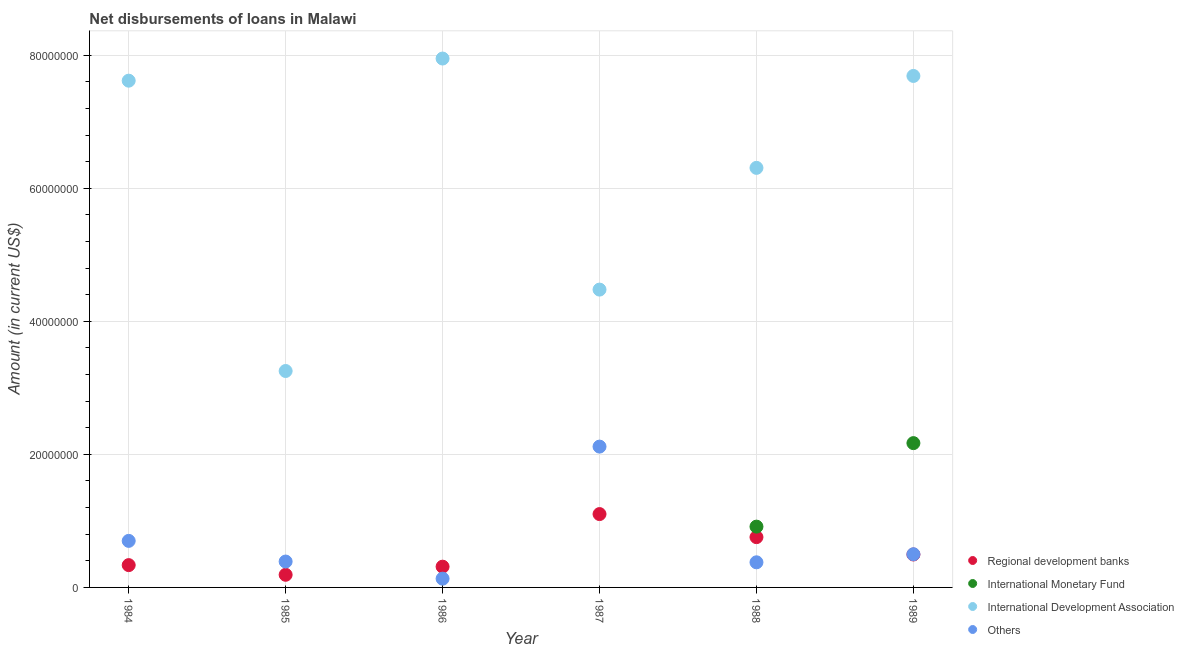Is the number of dotlines equal to the number of legend labels?
Make the answer very short. No. What is the amount of loan disimbursed by other organisations in 1988?
Ensure brevity in your answer.  3.78e+06. Across all years, what is the maximum amount of loan disimbursed by other organisations?
Provide a short and direct response. 2.12e+07. Across all years, what is the minimum amount of loan disimbursed by international development association?
Provide a short and direct response. 3.25e+07. What is the total amount of loan disimbursed by international development association in the graph?
Provide a succinct answer. 3.73e+08. What is the difference between the amount of loan disimbursed by international monetary fund in 1988 and that in 1989?
Make the answer very short. -1.26e+07. What is the difference between the amount of loan disimbursed by international development association in 1986 and the amount of loan disimbursed by international monetary fund in 1984?
Make the answer very short. 7.95e+07. What is the average amount of loan disimbursed by international monetary fund per year?
Your response must be concise. 5.14e+06. In the year 1988, what is the difference between the amount of loan disimbursed by international monetary fund and amount of loan disimbursed by regional development banks?
Offer a very short reply. 1.58e+06. In how many years, is the amount of loan disimbursed by international development association greater than 52000000 US$?
Offer a very short reply. 4. What is the ratio of the amount of loan disimbursed by international development association in 1985 to that in 1986?
Your answer should be compact. 0.41. What is the difference between the highest and the second highest amount of loan disimbursed by other organisations?
Make the answer very short. 1.42e+07. What is the difference between the highest and the lowest amount of loan disimbursed by international development association?
Keep it short and to the point. 4.70e+07. Is the sum of the amount of loan disimbursed by international development association in 1988 and 1989 greater than the maximum amount of loan disimbursed by other organisations across all years?
Your answer should be very brief. Yes. Is it the case that in every year, the sum of the amount of loan disimbursed by regional development banks and amount of loan disimbursed by international monetary fund is greater than the amount of loan disimbursed by international development association?
Ensure brevity in your answer.  No. Does the amount of loan disimbursed by other organisations monotonically increase over the years?
Offer a terse response. No. How many dotlines are there?
Offer a terse response. 4. How many years are there in the graph?
Provide a succinct answer. 6. Are the values on the major ticks of Y-axis written in scientific E-notation?
Offer a terse response. No. Does the graph contain grids?
Offer a terse response. Yes. Where does the legend appear in the graph?
Provide a short and direct response. Bottom right. How many legend labels are there?
Keep it short and to the point. 4. What is the title of the graph?
Your answer should be very brief. Net disbursements of loans in Malawi. What is the label or title of the Y-axis?
Offer a terse response. Amount (in current US$). What is the Amount (in current US$) in Regional development banks in 1984?
Offer a terse response. 3.35e+06. What is the Amount (in current US$) of International Monetary Fund in 1984?
Your response must be concise. 0. What is the Amount (in current US$) of International Development Association in 1984?
Make the answer very short. 7.62e+07. What is the Amount (in current US$) of Others in 1984?
Offer a very short reply. 7.00e+06. What is the Amount (in current US$) of Regional development banks in 1985?
Keep it short and to the point. 1.90e+06. What is the Amount (in current US$) in International Monetary Fund in 1985?
Provide a succinct answer. 0. What is the Amount (in current US$) in International Development Association in 1985?
Your answer should be very brief. 3.25e+07. What is the Amount (in current US$) of Others in 1985?
Provide a short and direct response. 3.89e+06. What is the Amount (in current US$) in Regional development banks in 1986?
Give a very brief answer. 3.12e+06. What is the Amount (in current US$) of International Monetary Fund in 1986?
Offer a terse response. 0. What is the Amount (in current US$) of International Development Association in 1986?
Provide a short and direct response. 7.95e+07. What is the Amount (in current US$) of Others in 1986?
Provide a short and direct response. 1.32e+06. What is the Amount (in current US$) of Regional development banks in 1987?
Your response must be concise. 1.10e+07. What is the Amount (in current US$) in International Monetary Fund in 1987?
Make the answer very short. 0. What is the Amount (in current US$) of International Development Association in 1987?
Provide a succinct answer. 4.48e+07. What is the Amount (in current US$) in Others in 1987?
Your answer should be very brief. 2.12e+07. What is the Amount (in current US$) in Regional development banks in 1988?
Offer a terse response. 7.56e+06. What is the Amount (in current US$) in International Monetary Fund in 1988?
Ensure brevity in your answer.  9.14e+06. What is the Amount (in current US$) in International Development Association in 1988?
Ensure brevity in your answer.  6.31e+07. What is the Amount (in current US$) in Others in 1988?
Offer a terse response. 3.78e+06. What is the Amount (in current US$) of Regional development banks in 1989?
Provide a short and direct response. 4.95e+06. What is the Amount (in current US$) of International Monetary Fund in 1989?
Make the answer very short. 2.17e+07. What is the Amount (in current US$) of International Development Association in 1989?
Give a very brief answer. 7.69e+07. What is the Amount (in current US$) of Others in 1989?
Keep it short and to the point. 4.99e+06. Across all years, what is the maximum Amount (in current US$) in Regional development banks?
Your answer should be very brief. 1.10e+07. Across all years, what is the maximum Amount (in current US$) of International Monetary Fund?
Make the answer very short. 2.17e+07. Across all years, what is the maximum Amount (in current US$) of International Development Association?
Make the answer very short. 7.95e+07. Across all years, what is the maximum Amount (in current US$) of Others?
Your answer should be very brief. 2.12e+07. Across all years, what is the minimum Amount (in current US$) in Regional development banks?
Offer a very short reply. 1.90e+06. Across all years, what is the minimum Amount (in current US$) in International Monetary Fund?
Offer a very short reply. 0. Across all years, what is the minimum Amount (in current US$) in International Development Association?
Give a very brief answer. 3.25e+07. Across all years, what is the minimum Amount (in current US$) of Others?
Give a very brief answer. 1.32e+06. What is the total Amount (in current US$) in Regional development banks in the graph?
Ensure brevity in your answer.  3.19e+07. What is the total Amount (in current US$) in International Monetary Fund in the graph?
Provide a short and direct response. 3.08e+07. What is the total Amount (in current US$) in International Development Association in the graph?
Keep it short and to the point. 3.73e+08. What is the total Amount (in current US$) in Others in the graph?
Provide a short and direct response. 4.21e+07. What is the difference between the Amount (in current US$) in Regional development banks in 1984 and that in 1985?
Give a very brief answer. 1.45e+06. What is the difference between the Amount (in current US$) in International Development Association in 1984 and that in 1985?
Offer a very short reply. 4.36e+07. What is the difference between the Amount (in current US$) of Others in 1984 and that in 1985?
Give a very brief answer. 3.11e+06. What is the difference between the Amount (in current US$) in Regional development banks in 1984 and that in 1986?
Offer a terse response. 2.34e+05. What is the difference between the Amount (in current US$) in International Development Association in 1984 and that in 1986?
Provide a succinct answer. -3.33e+06. What is the difference between the Amount (in current US$) of Others in 1984 and that in 1986?
Provide a succinct answer. 5.68e+06. What is the difference between the Amount (in current US$) in Regional development banks in 1984 and that in 1987?
Provide a short and direct response. -7.67e+06. What is the difference between the Amount (in current US$) in International Development Association in 1984 and that in 1987?
Give a very brief answer. 3.14e+07. What is the difference between the Amount (in current US$) in Others in 1984 and that in 1987?
Offer a very short reply. -1.42e+07. What is the difference between the Amount (in current US$) in Regional development banks in 1984 and that in 1988?
Ensure brevity in your answer.  -4.21e+06. What is the difference between the Amount (in current US$) in International Development Association in 1984 and that in 1988?
Make the answer very short. 1.31e+07. What is the difference between the Amount (in current US$) of Others in 1984 and that in 1988?
Keep it short and to the point. 3.22e+06. What is the difference between the Amount (in current US$) of Regional development banks in 1984 and that in 1989?
Your answer should be very brief. -1.60e+06. What is the difference between the Amount (in current US$) in International Development Association in 1984 and that in 1989?
Your answer should be very brief. -7.12e+05. What is the difference between the Amount (in current US$) of Others in 1984 and that in 1989?
Ensure brevity in your answer.  2.01e+06. What is the difference between the Amount (in current US$) of Regional development banks in 1985 and that in 1986?
Your response must be concise. -1.22e+06. What is the difference between the Amount (in current US$) of International Development Association in 1985 and that in 1986?
Your answer should be very brief. -4.70e+07. What is the difference between the Amount (in current US$) of Others in 1985 and that in 1986?
Keep it short and to the point. 2.58e+06. What is the difference between the Amount (in current US$) in Regional development banks in 1985 and that in 1987?
Your answer should be very brief. -9.13e+06. What is the difference between the Amount (in current US$) in International Development Association in 1985 and that in 1987?
Your response must be concise. -1.22e+07. What is the difference between the Amount (in current US$) in Others in 1985 and that in 1987?
Your answer should be very brief. -1.73e+07. What is the difference between the Amount (in current US$) in Regional development banks in 1985 and that in 1988?
Make the answer very short. -5.66e+06. What is the difference between the Amount (in current US$) of International Development Association in 1985 and that in 1988?
Your response must be concise. -3.05e+07. What is the difference between the Amount (in current US$) of Others in 1985 and that in 1988?
Give a very brief answer. 1.15e+05. What is the difference between the Amount (in current US$) of Regional development banks in 1985 and that in 1989?
Your response must be concise. -3.05e+06. What is the difference between the Amount (in current US$) of International Development Association in 1985 and that in 1989?
Keep it short and to the point. -4.44e+07. What is the difference between the Amount (in current US$) of Others in 1985 and that in 1989?
Keep it short and to the point. -1.10e+06. What is the difference between the Amount (in current US$) in Regional development banks in 1986 and that in 1987?
Keep it short and to the point. -7.91e+06. What is the difference between the Amount (in current US$) of International Development Association in 1986 and that in 1987?
Offer a very short reply. 3.47e+07. What is the difference between the Amount (in current US$) of Others in 1986 and that in 1987?
Offer a terse response. -1.99e+07. What is the difference between the Amount (in current US$) in Regional development banks in 1986 and that in 1988?
Offer a terse response. -4.44e+06. What is the difference between the Amount (in current US$) of International Development Association in 1986 and that in 1988?
Ensure brevity in your answer.  1.64e+07. What is the difference between the Amount (in current US$) in Others in 1986 and that in 1988?
Offer a very short reply. -2.46e+06. What is the difference between the Amount (in current US$) of Regional development banks in 1986 and that in 1989?
Provide a succinct answer. -1.83e+06. What is the difference between the Amount (in current US$) of International Development Association in 1986 and that in 1989?
Ensure brevity in your answer.  2.62e+06. What is the difference between the Amount (in current US$) in Others in 1986 and that in 1989?
Make the answer very short. -3.67e+06. What is the difference between the Amount (in current US$) in Regional development banks in 1987 and that in 1988?
Your answer should be compact. 3.47e+06. What is the difference between the Amount (in current US$) of International Development Association in 1987 and that in 1988?
Offer a very short reply. -1.83e+07. What is the difference between the Amount (in current US$) in Others in 1987 and that in 1988?
Ensure brevity in your answer.  1.74e+07. What is the difference between the Amount (in current US$) in Regional development banks in 1987 and that in 1989?
Offer a terse response. 6.08e+06. What is the difference between the Amount (in current US$) of International Development Association in 1987 and that in 1989?
Keep it short and to the point. -3.21e+07. What is the difference between the Amount (in current US$) in Others in 1987 and that in 1989?
Give a very brief answer. 1.62e+07. What is the difference between the Amount (in current US$) of Regional development banks in 1988 and that in 1989?
Offer a very short reply. 2.61e+06. What is the difference between the Amount (in current US$) of International Monetary Fund in 1988 and that in 1989?
Keep it short and to the point. -1.26e+07. What is the difference between the Amount (in current US$) of International Development Association in 1988 and that in 1989?
Offer a terse response. -1.38e+07. What is the difference between the Amount (in current US$) of Others in 1988 and that in 1989?
Provide a short and direct response. -1.21e+06. What is the difference between the Amount (in current US$) of Regional development banks in 1984 and the Amount (in current US$) of International Development Association in 1985?
Give a very brief answer. -2.92e+07. What is the difference between the Amount (in current US$) of Regional development banks in 1984 and the Amount (in current US$) of Others in 1985?
Ensure brevity in your answer.  -5.38e+05. What is the difference between the Amount (in current US$) of International Development Association in 1984 and the Amount (in current US$) of Others in 1985?
Make the answer very short. 7.23e+07. What is the difference between the Amount (in current US$) of Regional development banks in 1984 and the Amount (in current US$) of International Development Association in 1986?
Your response must be concise. -7.62e+07. What is the difference between the Amount (in current US$) of Regional development banks in 1984 and the Amount (in current US$) of Others in 1986?
Your answer should be compact. 2.04e+06. What is the difference between the Amount (in current US$) in International Development Association in 1984 and the Amount (in current US$) in Others in 1986?
Keep it short and to the point. 7.49e+07. What is the difference between the Amount (in current US$) of Regional development banks in 1984 and the Amount (in current US$) of International Development Association in 1987?
Your answer should be very brief. -4.14e+07. What is the difference between the Amount (in current US$) in Regional development banks in 1984 and the Amount (in current US$) in Others in 1987?
Keep it short and to the point. -1.78e+07. What is the difference between the Amount (in current US$) in International Development Association in 1984 and the Amount (in current US$) in Others in 1987?
Offer a terse response. 5.50e+07. What is the difference between the Amount (in current US$) in Regional development banks in 1984 and the Amount (in current US$) in International Monetary Fund in 1988?
Your response must be concise. -5.78e+06. What is the difference between the Amount (in current US$) of Regional development banks in 1984 and the Amount (in current US$) of International Development Association in 1988?
Offer a terse response. -5.97e+07. What is the difference between the Amount (in current US$) in Regional development banks in 1984 and the Amount (in current US$) in Others in 1988?
Your answer should be very brief. -4.23e+05. What is the difference between the Amount (in current US$) of International Development Association in 1984 and the Amount (in current US$) of Others in 1988?
Provide a short and direct response. 7.24e+07. What is the difference between the Amount (in current US$) of Regional development banks in 1984 and the Amount (in current US$) of International Monetary Fund in 1989?
Provide a succinct answer. -1.83e+07. What is the difference between the Amount (in current US$) of Regional development banks in 1984 and the Amount (in current US$) of International Development Association in 1989?
Keep it short and to the point. -7.35e+07. What is the difference between the Amount (in current US$) in Regional development banks in 1984 and the Amount (in current US$) in Others in 1989?
Your response must be concise. -1.64e+06. What is the difference between the Amount (in current US$) of International Development Association in 1984 and the Amount (in current US$) of Others in 1989?
Your answer should be very brief. 7.12e+07. What is the difference between the Amount (in current US$) in Regional development banks in 1985 and the Amount (in current US$) in International Development Association in 1986?
Make the answer very short. -7.76e+07. What is the difference between the Amount (in current US$) in Regional development banks in 1985 and the Amount (in current US$) in Others in 1986?
Your answer should be very brief. 5.84e+05. What is the difference between the Amount (in current US$) of International Development Association in 1985 and the Amount (in current US$) of Others in 1986?
Ensure brevity in your answer.  3.12e+07. What is the difference between the Amount (in current US$) of Regional development banks in 1985 and the Amount (in current US$) of International Development Association in 1987?
Offer a very short reply. -4.29e+07. What is the difference between the Amount (in current US$) of Regional development banks in 1985 and the Amount (in current US$) of Others in 1987?
Provide a succinct answer. -1.93e+07. What is the difference between the Amount (in current US$) of International Development Association in 1985 and the Amount (in current US$) of Others in 1987?
Your response must be concise. 1.14e+07. What is the difference between the Amount (in current US$) in Regional development banks in 1985 and the Amount (in current US$) in International Monetary Fund in 1988?
Give a very brief answer. -7.24e+06. What is the difference between the Amount (in current US$) in Regional development banks in 1985 and the Amount (in current US$) in International Development Association in 1988?
Keep it short and to the point. -6.12e+07. What is the difference between the Amount (in current US$) in Regional development banks in 1985 and the Amount (in current US$) in Others in 1988?
Give a very brief answer. -1.88e+06. What is the difference between the Amount (in current US$) in International Development Association in 1985 and the Amount (in current US$) in Others in 1988?
Offer a very short reply. 2.88e+07. What is the difference between the Amount (in current US$) in Regional development banks in 1985 and the Amount (in current US$) in International Monetary Fund in 1989?
Your answer should be compact. -1.98e+07. What is the difference between the Amount (in current US$) in Regional development banks in 1985 and the Amount (in current US$) in International Development Association in 1989?
Ensure brevity in your answer.  -7.50e+07. What is the difference between the Amount (in current US$) in Regional development banks in 1985 and the Amount (in current US$) in Others in 1989?
Keep it short and to the point. -3.09e+06. What is the difference between the Amount (in current US$) of International Development Association in 1985 and the Amount (in current US$) of Others in 1989?
Your answer should be compact. 2.75e+07. What is the difference between the Amount (in current US$) in Regional development banks in 1986 and the Amount (in current US$) in International Development Association in 1987?
Offer a terse response. -4.17e+07. What is the difference between the Amount (in current US$) in Regional development banks in 1986 and the Amount (in current US$) in Others in 1987?
Your response must be concise. -1.80e+07. What is the difference between the Amount (in current US$) in International Development Association in 1986 and the Amount (in current US$) in Others in 1987?
Ensure brevity in your answer.  5.83e+07. What is the difference between the Amount (in current US$) in Regional development banks in 1986 and the Amount (in current US$) in International Monetary Fund in 1988?
Make the answer very short. -6.02e+06. What is the difference between the Amount (in current US$) of Regional development banks in 1986 and the Amount (in current US$) of International Development Association in 1988?
Make the answer very short. -6.00e+07. What is the difference between the Amount (in current US$) in Regional development banks in 1986 and the Amount (in current US$) in Others in 1988?
Ensure brevity in your answer.  -6.57e+05. What is the difference between the Amount (in current US$) in International Development Association in 1986 and the Amount (in current US$) in Others in 1988?
Offer a terse response. 7.57e+07. What is the difference between the Amount (in current US$) in Regional development banks in 1986 and the Amount (in current US$) in International Monetary Fund in 1989?
Give a very brief answer. -1.86e+07. What is the difference between the Amount (in current US$) in Regional development banks in 1986 and the Amount (in current US$) in International Development Association in 1989?
Provide a succinct answer. -7.38e+07. What is the difference between the Amount (in current US$) in Regional development banks in 1986 and the Amount (in current US$) in Others in 1989?
Your response must be concise. -1.87e+06. What is the difference between the Amount (in current US$) in International Development Association in 1986 and the Amount (in current US$) in Others in 1989?
Ensure brevity in your answer.  7.45e+07. What is the difference between the Amount (in current US$) in Regional development banks in 1987 and the Amount (in current US$) in International Monetary Fund in 1988?
Offer a terse response. 1.89e+06. What is the difference between the Amount (in current US$) of Regional development banks in 1987 and the Amount (in current US$) of International Development Association in 1988?
Your answer should be very brief. -5.20e+07. What is the difference between the Amount (in current US$) of Regional development banks in 1987 and the Amount (in current US$) of Others in 1988?
Keep it short and to the point. 7.25e+06. What is the difference between the Amount (in current US$) in International Development Association in 1987 and the Amount (in current US$) in Others in 1988?
Your answer should be very brief. 4.10e+07. What is the difference between the Amount (in current US$) of Regional development banks in 1987 and the Amount (in current US$) of International Monetary Fund in 1989?
Keep it short and to the point. -1.07e+07. What is the difference between the Amount (in current US$) in Regional development banks in 1987 and the Amount (in current US$) in International Development Association in 1989?
Make the answer very short. -6.59e+07. What is the difference between the Amount (in current US$) of Regional development banks in 1987 and the Amount (in current US$) of Others in 1989?
Keep it short and to the point. 6.04e+06. What is the difference between the Amount (in current US$) in International Development Association in 1987 and the Amount (in current US$) in Others in 1989?
Offer a very short reply. 3.98e+07. What is the difference between the Amount (in current US$) in Regional development banks in 1988 and the Amount (in current US$) in International Monetary Fund in 1989?
Provide a succinct answer. -1.41e+07. What is the difference between the Amount (in current US$) in Regional development banks in 1988 and the Amount (in current US$) in International Development Association in 1989?
Your response must be concise. -6.93e+07. What is the difference between the Amount (in current US$) of Regional development banks in 1988 and the Amount (in current US$) of Others in 1989?
Give a very brief answer. 2.57e+06. What is the difference between the Amount (in current US$) in International Monetary Fund in 1988 and the Amount (in current US$) in International Development Association in 1989?
Ensure brevity in your answer.  -6.78e+07. What is the difference between the Amount (in current US$) of International Monetary Fund in 1988 and the Amount (in current US$) of Others in 1989?
Provide a short and direct response. 4.15e+06. What is the difference between the Amount (in current US$) of International Development Association in 1988 and the Amount (in current US$) of Others in 1989?
Ensure brevity in your answer.  5.81e+07. What is the average Amount (in current US$) in Regional development banks per year?
Offer a terse response. 5.32e+06. What is the average Amount (in current US$) in International Monetary Fund per year?
Make the answer very short. 5.14e+06. What is the average Amount (in current US$) of International Development Association per year?
Make the answer very short. 6.22e+07. What is the average Amount (in current US$) in Others per year?
Offer a very short reply. 7.02e+06. In the year 1984, what is the difference between the Amount (in current US$) of Regional development banks and Amount (in current US$) of International Development Association?
Your answer should be very brief. -7.28e+07. In the year 1984, what is the difference between the Amount (in current US$) in Regional development banks and Amount (in current US$) in Others?
Make the answer very short. -3.64e+06. In the year 1984, what is the difference between the Amount (in current US$) of International Development Association and Amount (in current US$) of Others?
Provide a short and direct response. 6.92e+07. In the year 1985, what is the difference between the Amount (in current US$) of Regional development banks and Amount (in current US$) of International Development Association?
Offer a very short reply. -3.06e+07. In the year 1985, what is the difference between the Amount (in current US$) in Regional development banks and Amount (in current US$) in Others?
Keep it short and to the point. -1.99e+06. In the year 1985, what is the difference between the Amount (in current US$) in International Development Association and Amount (in current US$) in Others?
Ensure brevity in your answer.  2.86e+07. In the year 1986, what is the difference between the Amount (in current US$) in Regional development banks and Amount (in current US$) in International Development Association?
Provide a succinct answer. -7.64e+07. In the year 1986, what is the difference between the Amount (in current US$) in Regional development banks and Amount (in current US$) in Others?
Keep it short and to the point. 1.80e+06. In the year 1986, what is the difference between the Amount (in current US$) in International Development Association and Amount (in current US$) in Others?
Your answer should be compact. 7.82e+07. In the year 1987, what is the difference between the Amount (in current US$) in Regional development banks and Amount (in current US$) in International Development Association?
Give a very brief answer. -3.37e+07. In the year 1987, what is the difference between the Amount (in current US$) in Regional development banks and Amount (in current US$) in Others?
Provide a succinct answer. -1.01e+07. In the year 1987, what is the difference between the Amount (in current US$) in International Development Association and Amount (in current US$) in Others?
Provide a short and direct response. 2.36e+07. In the year 1988, what is the difference between the Amount (in current US$) of Regional development banks and Amount (in current US$) of International Monetary Fund?
Provide a succinct answer. -1.58e+06. In the year 1988, what is the difference between the Amount (in current US$) in Regional development banks and Amount (in current US$) in International Development Association?
Give a very brief answer. -5.55e+07. In the year 1988, what is the difference between the Amount (in current US$) in Regional development banks and Amount (in current US$) in Others?
Your response must be concise. 3.78e+06. In the year 1988, what is the difference between the Amount (in current US$) in International Monetary Fund and Amount (in current US$) in International Development Association?
Offer a very short reply. -5.39e+07. In the year 1988, what is the difference between the Amount (in current US$) of International Monetary Fund and Amount (in current US$) of Others?
Provide a succinct answer. 5.36e+06. In the year 1988, what is the difference between the Amount (in current US$) of International Development Association and Amount (in current US$) of Others?
Provide a short and direct response. 5.93e+07. In the year 1989, what is the difference between the Amount (in current US$) of Regional development banks and Amount (in current US$) of International Monetary Fund?
Your answer should be very brief. -1.67e+07. In the year 1989, what is the difference between the Amount (in current US$) in Regional development banks and Amount (in current US$) in International Development Association?
Make the answer very short. -7.19e+07. In the year 1989, what is the difference between the Amount (in current US$) of Regional development banks and Amount (in current US$) of Others?
Make the answer very short. -4.00e+04. In the year 1989, what is the difference between the Amount (in current US$) in International Monetary Fund and Amount (in current US$) in International Development Association?
Make the answer very short. -5.52e+07. In the year 1989, what is the difference between the Amount (in current US$) of International Monetary Fund and Amount (in current US$) of Others?
Keep it short and to the point. 1.67e+07. In the year 1989, what is the difference between the Amount (in current US$) in International Development Association and Amount (in current US$) in Others?
Your response must be concise. 7.19e+07. What is the ratio of the Amount (in current US$) of Regional development banks in 1984 to that in 1985?
Make the answer very short. 1.77. What is the ratio of the Amount (in current US$) in International Development Association in 1984 to that in 1985?
Offer a terse response. 2.34. What is the ratio of the Amount (in current US$) in Others in 1984 to that in 1985?
Provide a succinct answer. 1.8. What is the ratio of the Amount (in current US$) of Regional development banks in 1984 to that in 1986?
Offer a terse response. 1.07. What is the ratio of the Amount (in current US$) of International Development Association in 1984 to that in 1986?
Keep it short and to the point. 0.96. What is the ratio of the Amount (in current US$) of Others in 1984 to that in 1986?
Ensure brevity in your answer.  5.32. What is the ratio of the Amount (in current US$) of Regional development banks in 1984 to that in 1987?
Provide a succinct answer. 0.3. What is the ratio of the Amount (in current US$) of International Development Association in 1984 to that in 1987?
Keep it short and to the point. 1.7. What is the ratio of the Amount (in current US$) in Others in 1984 to that in 1987?
Give a very brief answer. 0.33. What is the ratio of the Amount (in current US$) of Regional development banks in 1984 to that in 1988?
Your answer should be compact. 0.44. What is the ratio of the Amount (in current US$) of International Development Association in 1984 to that in 1988?
Make the answer very short. 1.21. What is the ratio of the Amount (in current US$) of Others in 1984 to that in 1988?
Your answer should be very brief. 1.85. What is the ratio of the Amount (in current US$) of Regional development banks in 1984 to that in 1989?
Make the answer very short. 0.68. What is the ratio of the Amount (in current US$) in Others in 1984 to that in 1989?
Make the answer very short. 1.4. What is the ratio of the Amount (in current US$) of Regional development banks in 1985 to that in 1986?
Your answer should be compact. 0.61. What is the ratio of the Amount (in current US$) in International Development Association in 1985 to that in 1986?
Provide a succinct answer. 0.41. What is the ratio of the Amount (in current US$) of Others in 1985 to that in 1986?
Provide a succinct answer. 2.96. What is the ratio of the Amount (in current US$) of Regional development banks in 1985 to that in 1987?
Make the answer very short. 0.17. What is the ratio of the Amount (in current US$) in International Development Association in 1985 to that in 1987?
Give a very brief answer. 0.73. What is the ratio of the Amount (in current US$) in Others in 1985 to that in 1987?
Offer a terse response. 0.18. What is the ratio of the Amount (in current US$) of Regional development banks in 1985 to that in 1988?
Ensure brevity in your answer.  0.25. What is the ratio of the Amount (in current US$) of International Development Association in 1985 to that in 1988?
Your answer should be very brief. 0.52. What is the ratio of the Amount (in current US$) in Others in 1985 to that in 1988?
Provide a succinct answer. 1.03. What is the ratio of the Amount (in current US$) in Regional development banks in 1985 to that in 1989?
Give a very brief answer. 0.38. What is the ratio of the Amount (in current US$) in International Development Association in 1985 to that in 1989?
Offer a terse response. 0.42. What is the ratio of the Amount (in current US$) of Others in 1985 to that in 1989?
Keep it short and to the point. 0.78. What is the ratio of the Amount (in current US$) of Regional development banks in 1986 to that in 1987?
Keep it short and to the point. 0.28. What is the ratio of the Amount (in current US$) of International Development Association in 1986 to that in 1987?
Your answer should be very brief. 1.78. What is the ratio of the Amount (in current US$) of Others in 1986 to that in 1987?
Ensure brevity in your answer.  0.06. What is the ratio of the Amount (in current US$) of Regional development banks in 1986 to that in 1988?
Ensure brevity in your answer.  0.41. What is the ratio of the Amount (in current US$) in International Development Association in 1986 to that in 1988?
Offer a terse response. 1.26. What is the ratio of the Amount (in current US$) of Others in 1986 to that in 1988?
Keep it short and to the point. 0.35. What is the ratio of the Amount (in current US$) of Regional development banks in 1986 to that in 1989?
Your response must be concise. 0.63. What is the ratio of the Amount (in current US$) in International Development Association in 1986 to that in 1989?
Give a very brief answer. 1.03. What is the ratio of the Amount (in current US$) of Others in 1986 to that in 1989?
Keep it short and to the point. 0.26. What is the ratio of the Amount (in current US$) in Regional development banks in 1987 to that in 1988?
Provide a short and direct response. 1.46. What is the ratio of the Amount (in current US$) of International Development Association in 1987 to that in 1988?
Make the answer very short. 0.71. What is the ratio of the Amount (in current US$) of Others in 1987 to that in 1988?
Offer a terse response. 5.61. What is the ratio of the Amount (in current US$) of Regional development banks in 1987 to that in 1989?
Give a very brief answer. 2.23. What is the ratio of the Amount (in current US$) of International Development Association in 1987 to that in 1989?
Offer a very short reply. 0.58. What is the ratio of the Amount (in current US$) of Others in 1987 to that in 1989?
Offer a terse response. 4.24. What is the ratio of the Amount (in current US$) of Regional development banks in 1988 to that in 1989?
Provide a succinct answer. 1.53. What is the ratio of the Amount (in current US$) in International Monetary Fund in 1988 to that in 1989?
Your answer should be very brief. 0.42. What is the ratio of the Amount (in current US$) in International Development Association in 1988 to that in 1989?
Your answer should be very brief. 0.82. What is the ratio of the Amount (in current US$) in Others in 1988 to that in 1989?
Your answer should be very brief. 0.76. What is the difference between the highest and the second highest Amount (in current US$) of Regional development banks?
Your response must be concise. 3.47e+06. What is the difference between the highest and the second highest Amount (in current US$) in International Development Association?
Your answer should be compact. 2.62e+06. What is the difference between the highest and the second highest Amount (in current US$) in Others?
Offer a very short reply. 1.42e+07. What is the difference between the highest and the lowest Amount (in current US$) of Regional development banks?
Make the answer very short. 9.13e+06. What is the difference between the highest and the lowest Amount (in current US$) of International Monetary Fund?
Offer a very short reply. 2.17e+07. What is the difference between the highest and the lowest Amount (in current US$) of International Development Association?
Offer a terse response. 4.70e+07. What is the difference between the highest and the lowest Amount (in current US$) in Others?
Offer a very short reply. 1.99e+07. 